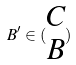Convert formula to latex. <formula><loc_0><loc_0><loc_500><loc_500>B ^ { \prime } \in ( \begin{matrix} C \\ B \end{matrix} )</formula> 